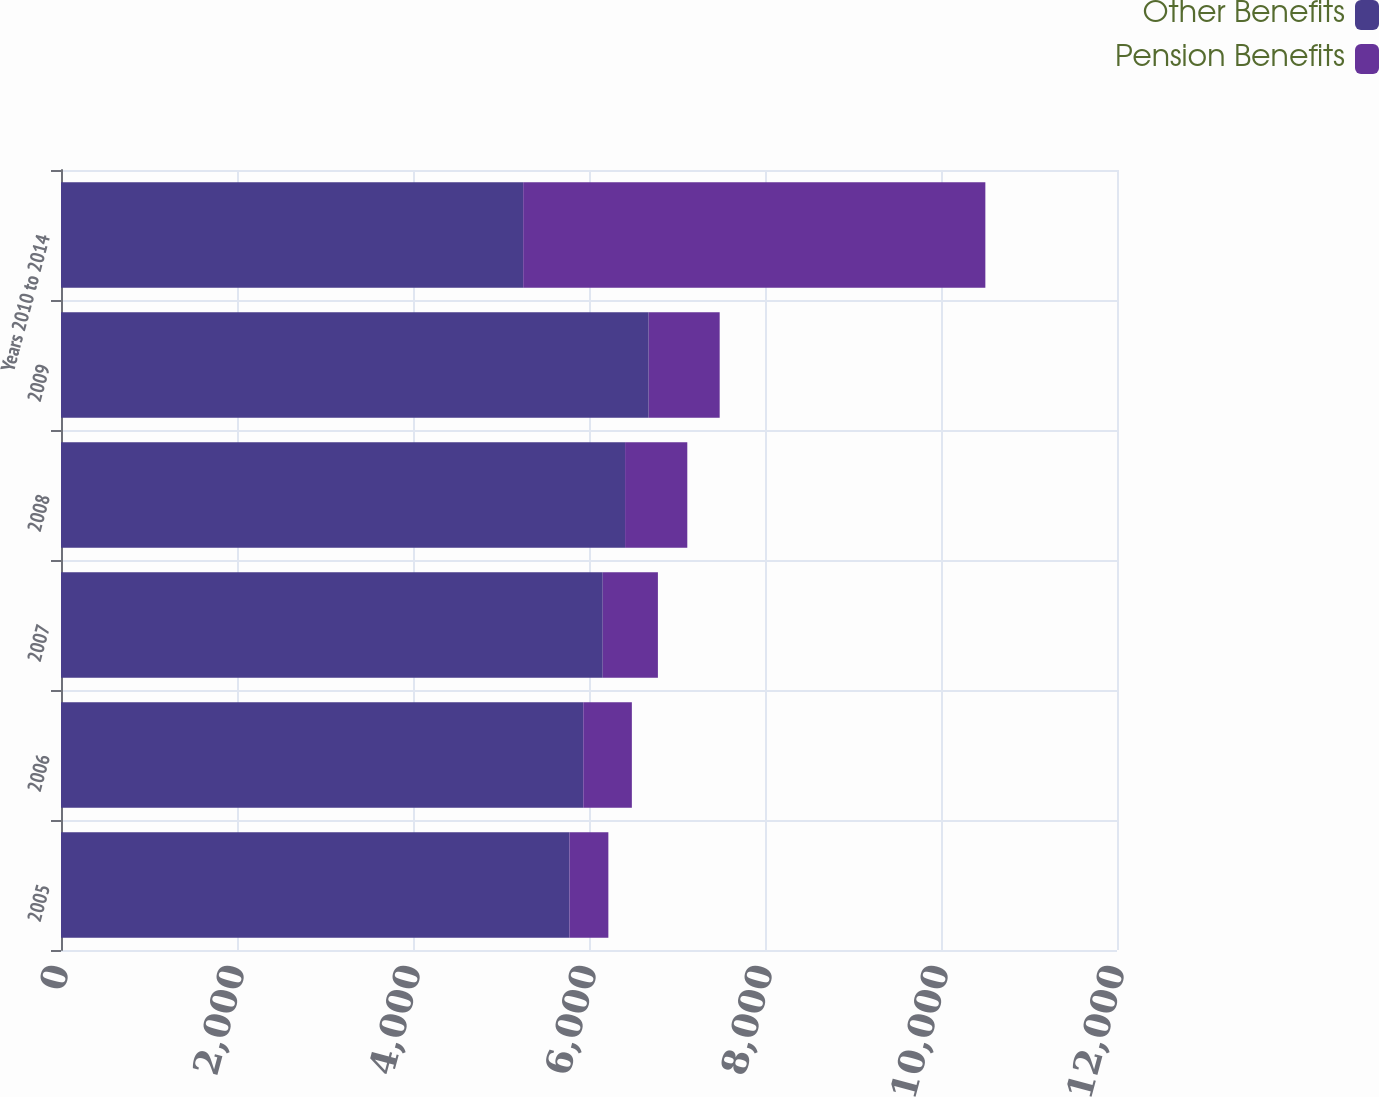<chart> <loc_0><loc_0><loc_500><loc_500><stacked_bar_chart><ecel><fcel>2005<fcel>2006<fcel>2007<fcel>2008<fcel>2009<fcel>Years 2010 to 2014<nl><fcel>Other Benefits<fcel>5779<fcel>5935<fcel>6156<fcel>6410<fcel>6678<fcel>5252<nl><fcel>Pension Benefits<fcel>441<fcel>552<fcel>627<fcel>707<fcel>807<fcel>5252<nl></chart> 